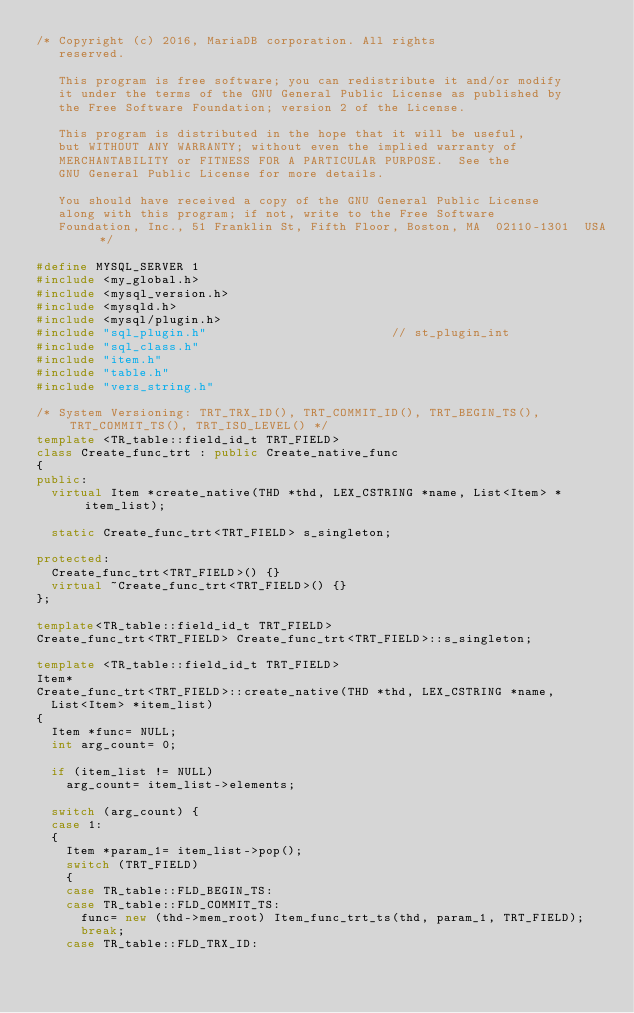<code> <loc_0><loc_0><loc_500><loc_500><_C++_>/* Copyright (c) 2016, MariaDB corporation. All rights
   reserved.

   This program is free software; you can redistribute it and/or modify
   it under the terms of the GNU General Public License as published by
   the Free Software Foundation; version 2 of the License.

   This program is distributed in the hope that it will be useful,
   but WITHOUT ANY WARRANTY; without even the implied warranty of
   MERCHANTABILITY or FITNESS FOR A PARTICULAR PURPOSE.  See the
   GNU General Public License for more details.

   You should have received a copy of the GNU General Public License
   along with this program; if not, write to the Free Software
   Foundation, Inc., 51 Franklin St, Fifth Floor, Boston, MA  02110-1301  USA */

#define MYSQL_SERVER 1
#include <my_global.h>
#include <mysql_version.h>
#include <mysqld.h>
#include <mysql/plugin.h>
#include "sql_plugin.h"                         // st_plugin_int
#include "sql_class.h"
#include "item.h"
#include "table.h"
#include "vers_string.h"

/* System Versioning: TRT_TRX_ID(), TRT_COMMIT_ID(), TRT_BEGIN_TS(), TRT_COMMIT_TS(), TRT_ISO_LEVEL() */
template <TR_table::field_id_t TRT_FIELD>
class Create_func_trt : public Create_native_func
{
public:
  virtual Item *create_native(THD *thd, LEX_CSTRING *name, List<Item> *item_list);

  static Create_func_trt<TRT_FIELD> s_singleton;

protected:
  Create_func_trt<TRT_FIELD>() {}
  virtual ~Create_func_trt<TRT_FIELD>() {}
};

template<TR_table::field_id_t TRT_FIELD>
Create_func_trt<TRT_FIELD> Create_func_trt<TRT_FIELD>::s_singleton;

template <TR_table::field_id_t TRT_FIELD>
Item*
Create_func_trt<TRT_FIELD>::create_native(THD *thd, LEX_CSTRING *name,
  List<Item> *item_list)
{
  Item *func= NULL;
  int arg_count= 0;

  if (item_list != NULL)
    arg_count= item_list->elements;

  switch (arg_count) {
  case 1:
  {
    Item *param_1= item_list->pop();
    switch (TRT_FIELD)
    {
    case TR_table::FLD_BEGIN_TS:
    case TR_table::FLD_COMMIT_TS:
      func= new (thd->mem_root) Item_func_trt_ts(thd, param_1, TRT_FIELD);
      break;
    case TR_table::FLD_TRX_ID:</code> 